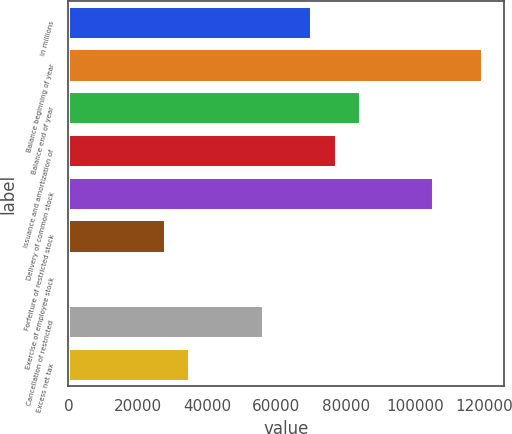<chart> <loc_0><loc_0><loc_500><loc_500><bar_chart><fcel>in millions<fcel>Balance beginning of year<fcel>Balance end of year<fcel>Issuance and amortization of<fcel>Delivery of common stock<fcel>Forfeiture of restricted stock<fcel>Exercise of employee stock<fcel>Cancellation of restricted<fcel>Excess net tax<nl><fcel>70379<fcel>119642<fcel>84454<fcel>77416.5<fcel>105566<fcel>28154<fcel>4<fcel>56304<fcel>35191.5<nl></chart> 